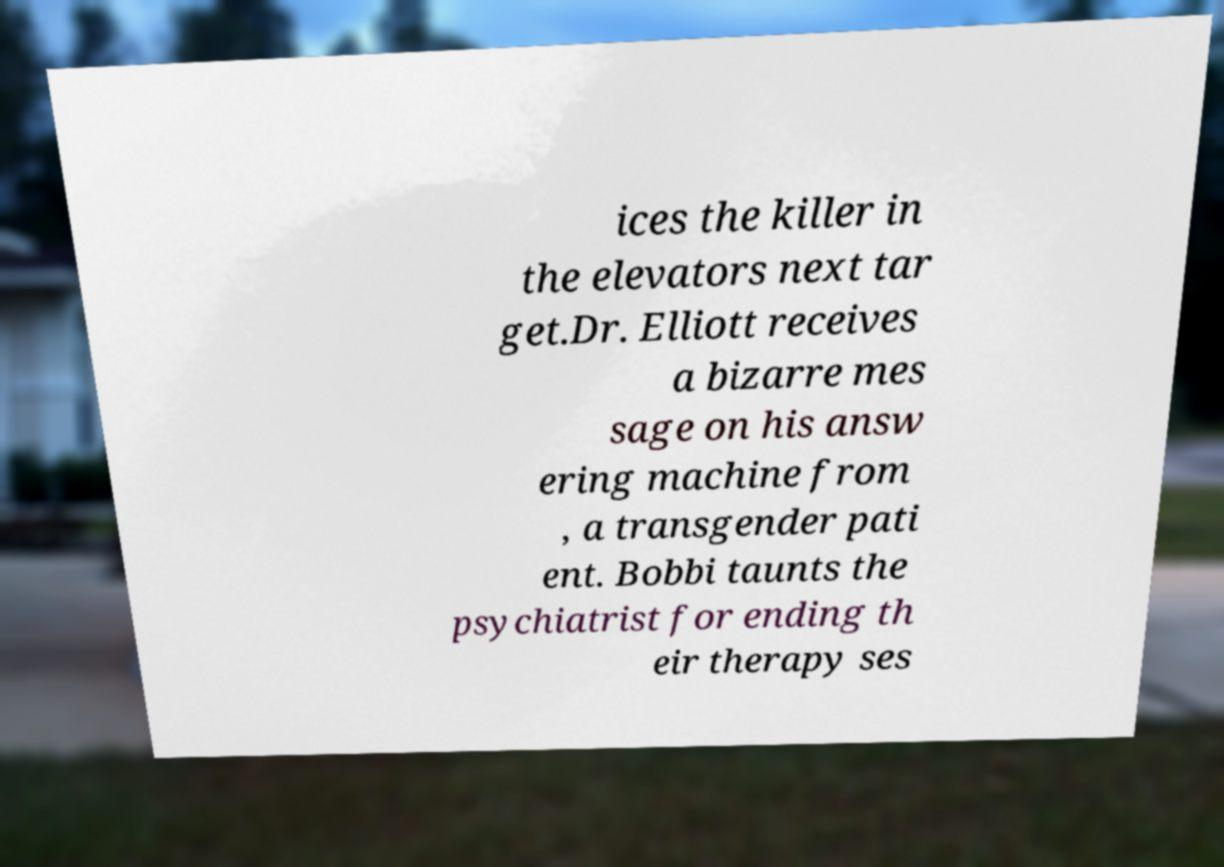Please read and relay the text visible in this image. What does it say? ices the killer in the elevators next tar get.Dr. Elliott receives a bizarre mes sage on his answ ering machine from , a transgender pati ent. Bobbi taunts the psychiatrist for ending th eir therapy ses 